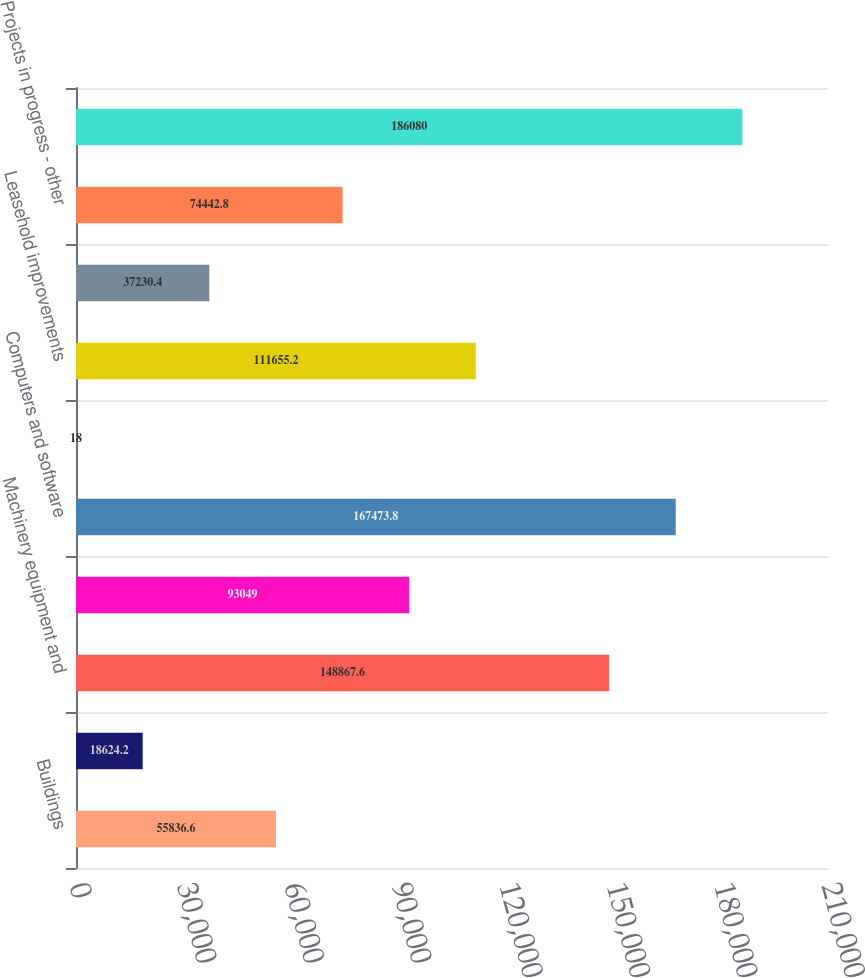<chart> <loc_0><loc_0><loc_500><loc_500><bar_chart><fcel>Buildings<fcel>Land<fcel>Machinery equipment and<fcel>Furniture and office equipment<fcel>Computers and software<fcel>Automobiles<fcel>Leasehold improvements<fcel>Projects in progress -<fcel>Projects in progress - other<fcel>Less accumulated depreciation<nl><fcel>55836.6<fcel>18624.2<fcel>148868<fcel>93049<fcel>167474<fcel>18<fcel>111655<fcel>37230.4<fcel>74442.8<fcel>186080<nl></chart> 